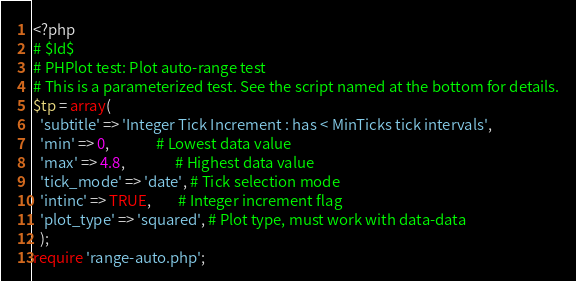Convert code to text. <code><loc_0><loc_0><loc_500><loc_500><_PHP_><?php
# $Id$
# PHPlot test: Plot auto-range test
# This is a parameterized test. See the script named at the bottom for details.
$tp = array(
  'subtitle' => 'Integer Tick Increment : has < MinTicks tick intervals',
  'min' => 0,              # Lowest data value
  'max' => 4.8,               # Highest data value
  'tick_mode' => 'date', # Tick selection mode
  'intinc' => TRUE,        # Integer increment flag
  'plot_type' => 'squared', # Plot type, must work with data-data
  );
require 'range-auto.php';
</code> 